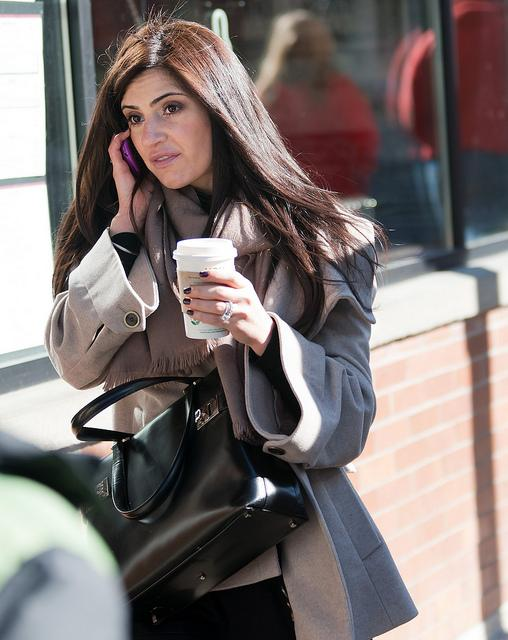What pick me up is found in this woman's cup?

Choices:
A) soy milk
B) foam
C) caffeine
D) milk caffeine 